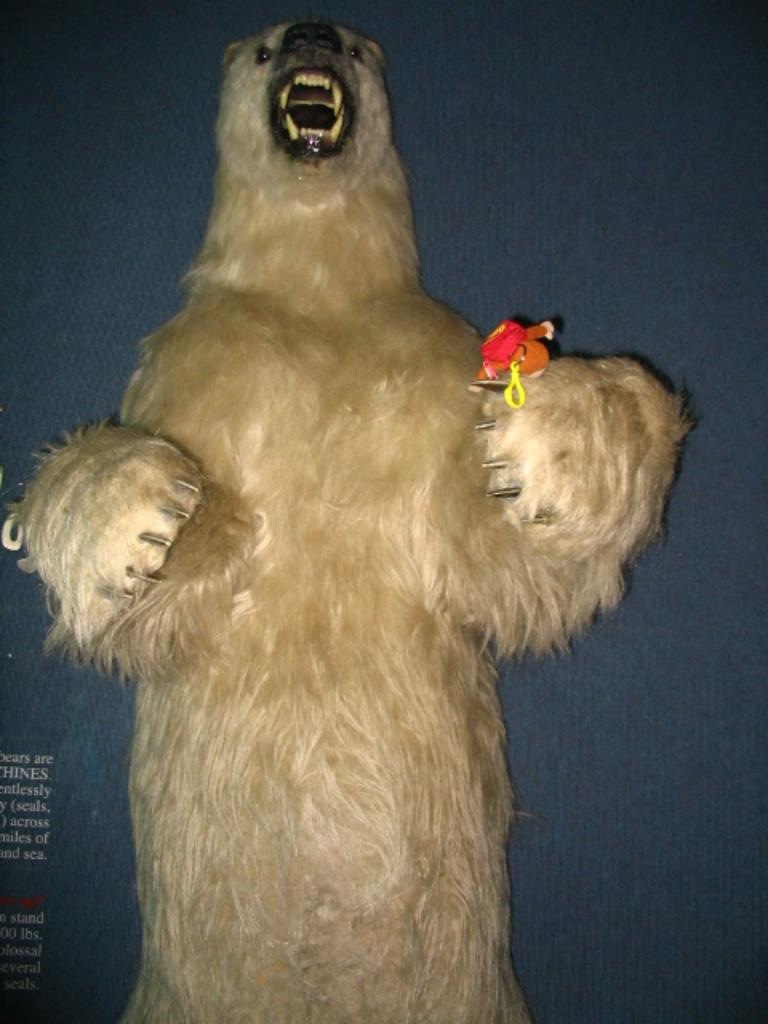What animal is the main subject of the image? There is a polar bear in the image. Where is the polar bear located in the image? The polar bear is in the front of the image. Is there any text present in the image? Yes, there is some text at the bottom left corner of the image. What type of string is the polar bear holding in the image? There is no string present in the image; the polar bear is not holding anything. 